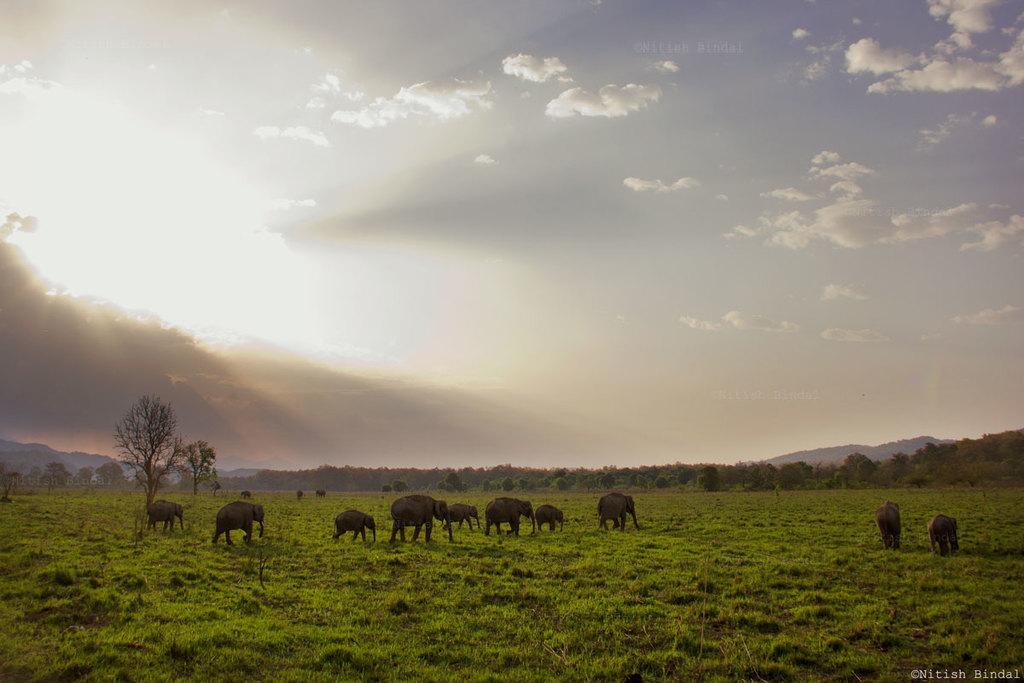Can you describe this image briefly? At the bottom of the image we can see elephants. In the background there are trees, hill and sky. 